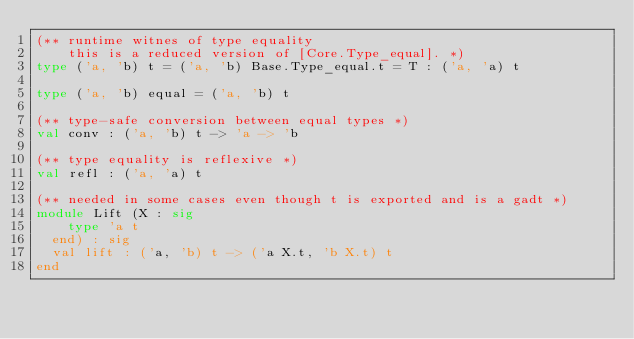Convert code to text. <code><loc_0><loc_0><loc_500><loc_500><_OCaml_>(** runtime witnes of type equality
    this is a reduced version of [Core.Type_equal]. *)
type ('a, 'b) t = ('a, 'b) Base.Type_equal.t = T : ('a, 'a) t

type ('a, 'b) equal = ('a, 'b) t

(** type-safe conversion between equal types *)
val conv : ('a, 'b) t -> 'a -> 'b

(** type equality is reflexive *)
val refl : ('a, 'a) t

(** needed in some cases even though t is exported and is a gadt *)
module Lift (X : sig
    type 'a t
  end) : sig
  val lift : ('a, 'b) t -> ('a X.t, 'b X.t) t
end
</code> 